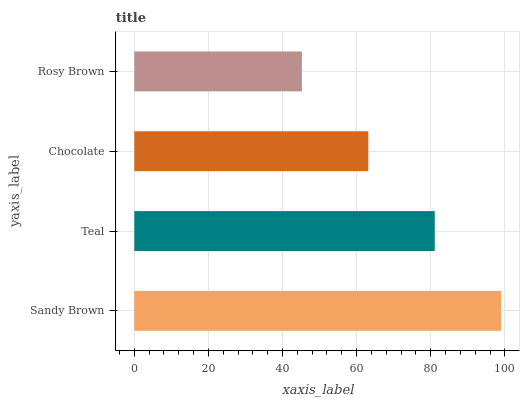Is Rosy Brown the minimum?
Answer yes or no. Yes. Is Sandy Brown the maximum?
Answer yes or no. Yes. Is Teal the minimum?
Answer yes or no. No. Is Teal the maximum?
Answer yes or no. No. Is Sandy Brown greater than Teal?
Answer yes or no. Yes. Is Teal less than Sandy Brown?
Answer yes or no. Yes. Is Teal greater than Sandy Brown?
Answer yes or no. No. Is Sandy Brown less than Teal?
Answer yes or no. No. Is Teal the high median?
Answer yes or no. Yes. Is Chocolate the low median?
Answer yes or no. Yes. Is Chocolate the high median?
Answer yes or no. No. Is Teal the low median?
Answer yes or no. No. 